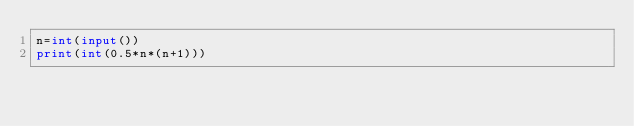Convert code to text. <code><loc_0><loc_0><loc_500><loc_500><_Python_>n=int(input())
print(int(0.5*n*(n+1)))</code> 